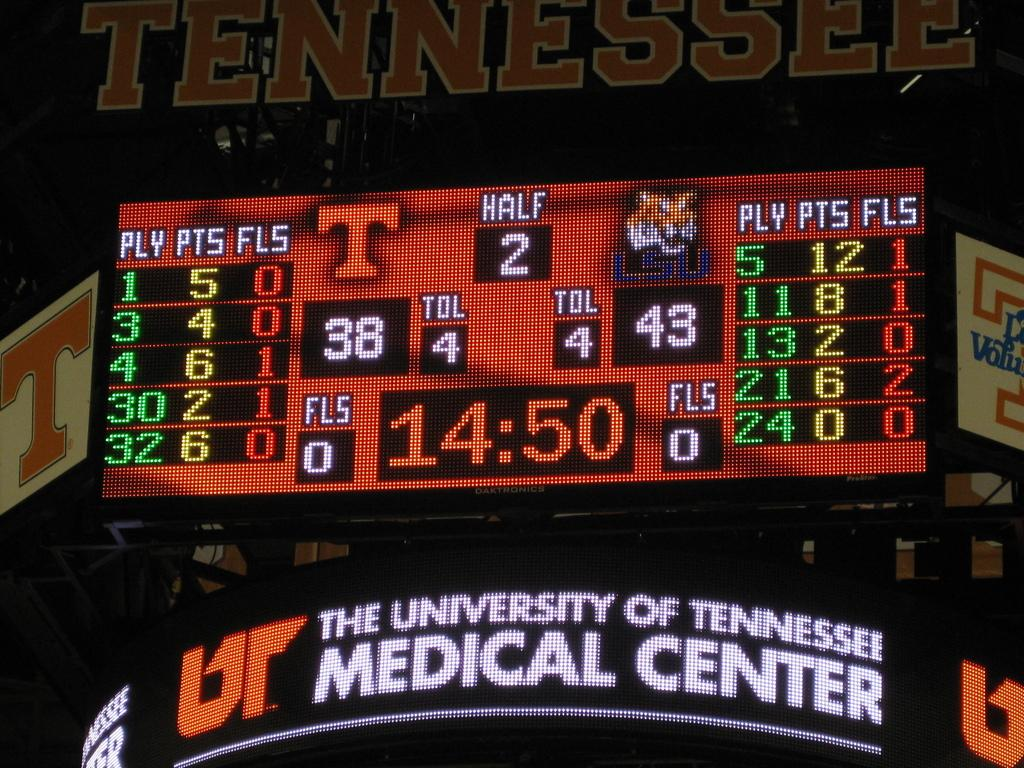<image>
Write a terse but informative summary of the picture. A UT score board shows a score of 38 to 4. 